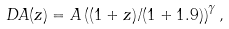Convert formula to latex. <formula><loc_0><loc_0><loc_500><loc_500>D A ( z ) = A \left ( ( 1 + z ) / ( 1 + 1 . 9 ) \right ) ^ { \gamma } ,</formula> 